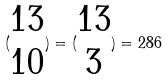Convert formula to latex. <formula><loc_0><loc_0><loc_500><loc_500>( \begin{matrix} 1 3 \\ 1 0 \end{matrix} ) = ( \begin{matrix} 1 3 \\ 3 \end{matrix} ) = 2 8 6</formula> 